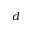Convert formula to latex. <formula><loc_0><loc_0><loc_500><loc_500>d</formula> 